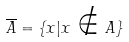Convert formula to latex. <formula><loc_0><loc_0><loc_500><loc_500>\overline { A } = \{ x | x \notin A \}</formula> 